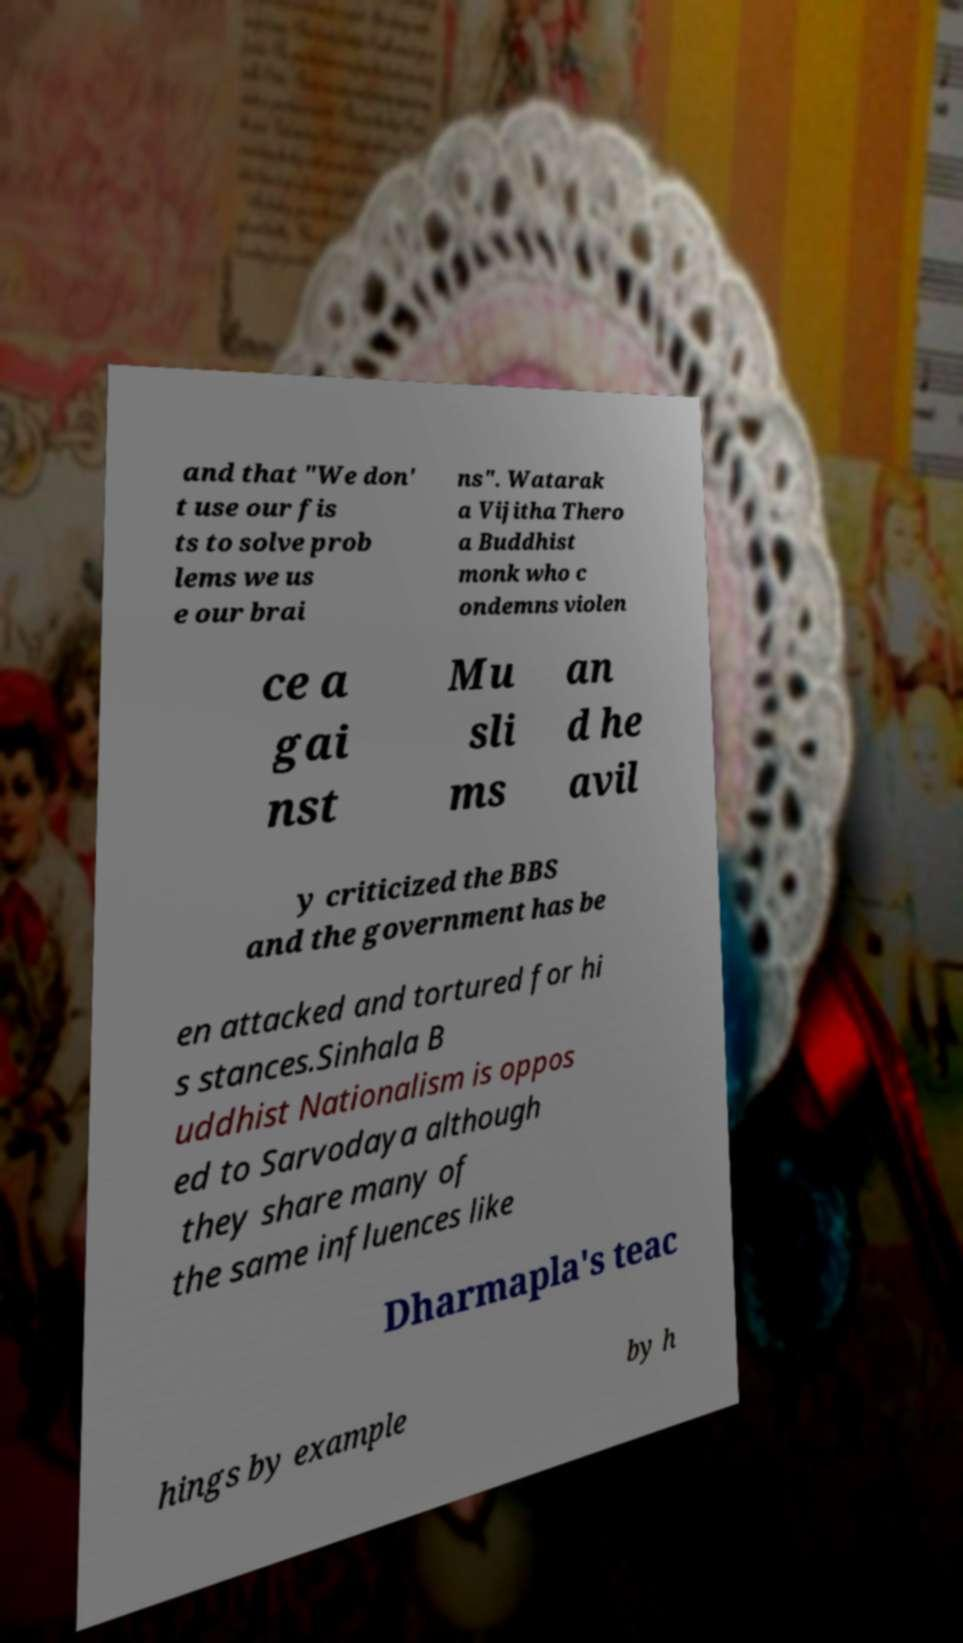Could you extract and type out the text from this image? and that "We don' t use our fis ts to solve prob lems we us e our brai ns". Watarak a Vijitha Thero a Buddhist monk who c ondemns violen ce a gai nst Mu sli ms an d he avil y criticized the BBS and the government has be en attacked and tortured for hi s stances.Sinhala B uddhist Nationalism is oppos ed to Sarvodaya although they share many of the same influences like Dharmapla's teac hings by example by h 